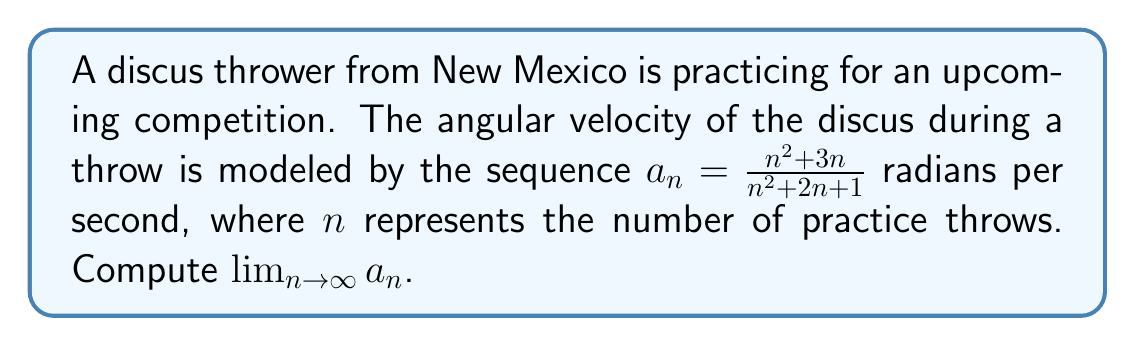Could you help me with this problem? To find the limit of the sequence as $n$ approaches infinity, we'll follow these steps:

1) First, let's examine the general term of the sequence:

   $$a_n = \frac{n^2 + 3n}{n^2 + 2n + 1}$$

2) To find the limit as $n$ approaches infinity, we can divide both the numerator and denominator by the highest power of $n$, which is $n^2$ in this case:

   $$\lim_{n \to \infty} a_n = \lim_{n \to \infty} \frac{n^2 + 3n}{n^2 + 2n + 1}$$
   $$= \lim_{n \to \infty} \frac{\frac{n^2}{n^2} + \frac{3n}{n^2}}{\frac{n^2}{n^2} + \frac{2n}{n^2} + \frac{1}{n^2}}$$
   $$= \lim_{n \to \infty} \frac{1 + \frac{3}{n}}{1 + \frac{2}{n} + \frac{1}{n^2}}$$

3) As $n$ approaches infinity, $\frac{1}{n}$ and $\frac{1}{n^2}$ approach 0:

   $$\lim_{n \to \infty} \frac{1 + 0}{1 + 0 + 0} = \frac{1}{1} = 1$$

Therefore, the limit of the sequence as $n$ approaches infinity is 1.
Answer: $\lim_{n \to \infty} a_n = 1$ 